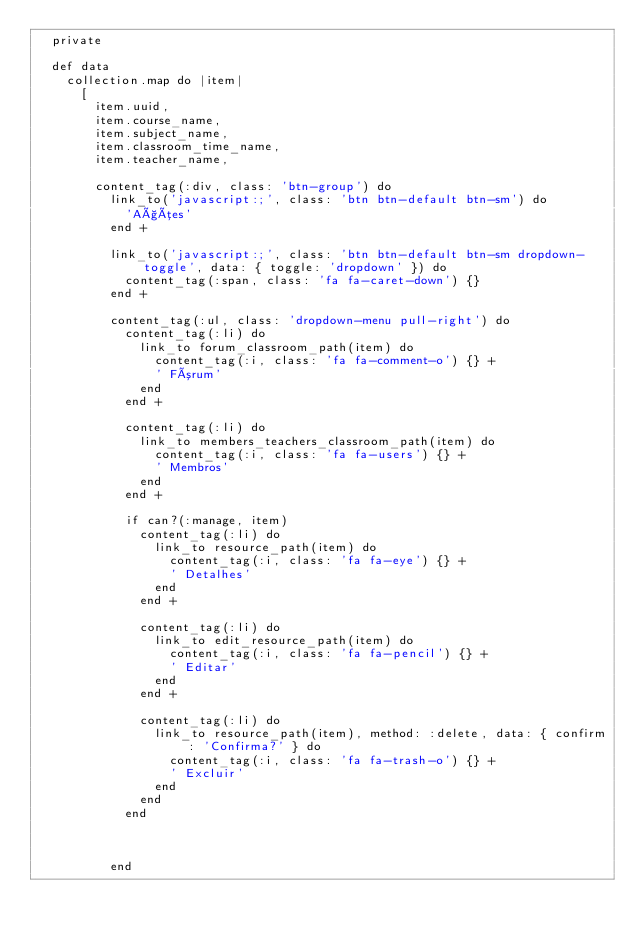<code> <loc_0><loc_0><loc_500><loc_500><_Ruby_>  private

  def data
    collection.map do |item|
      [
        item.uuid,
        item.course_name,
        item.subject_name,
        item.classroom_time_name,
        item.teacher_name,

        content_tag(:div, class: 'btn-group') do
          link_to('javascript:;', class: 'btn btn-default btn-sm') do
            'Ações'
          end +

          link_to('javascript:;', class: 'btn btn-default btn-sm dropdown-toggle', data: { toggle: 'dropdown' }) do
            content_tag(:span, class: 'fa fa-caret-down') {}
          end +

          content_tag(:ul, class: 'dropdown-menu pull-right') do
            content_tag(:li) do
              link_to forum_classroom_path(item) do
                content_tag(:i, class: 'fa fa-comment-o') {} +
                ' Fórum'
              end
            end +

            content_tag(:li) do
              link_to members_teachers_classroom_path(item) do
                content_tag(:i, class: 'fa fa-users') {} +
                ' Membros'
              end
            end +

            if can?(:manage, item)
              content_tag(:li) do
                link_to resource_path(item) do
                  content_tag(:i, class: 'fa fa-eye') {} +
                  ' Detalhes'
                end
              end +

              content_tag(:li) do
                link_to edit_resource_path(item) do
                  content_tag(:i, class: 'fa fa-pencil') {} +
                  ' Editar'
                end
              end +

              content_tag(:li) do
                link_to resource_path(item), method: :delete, data: { confirm: 'Confirma?' } do
                  content_tag(:i, class: 'fa fa-trash-o') {} +
                  ' Excluir'
                end
              end
            end



          end</code> 